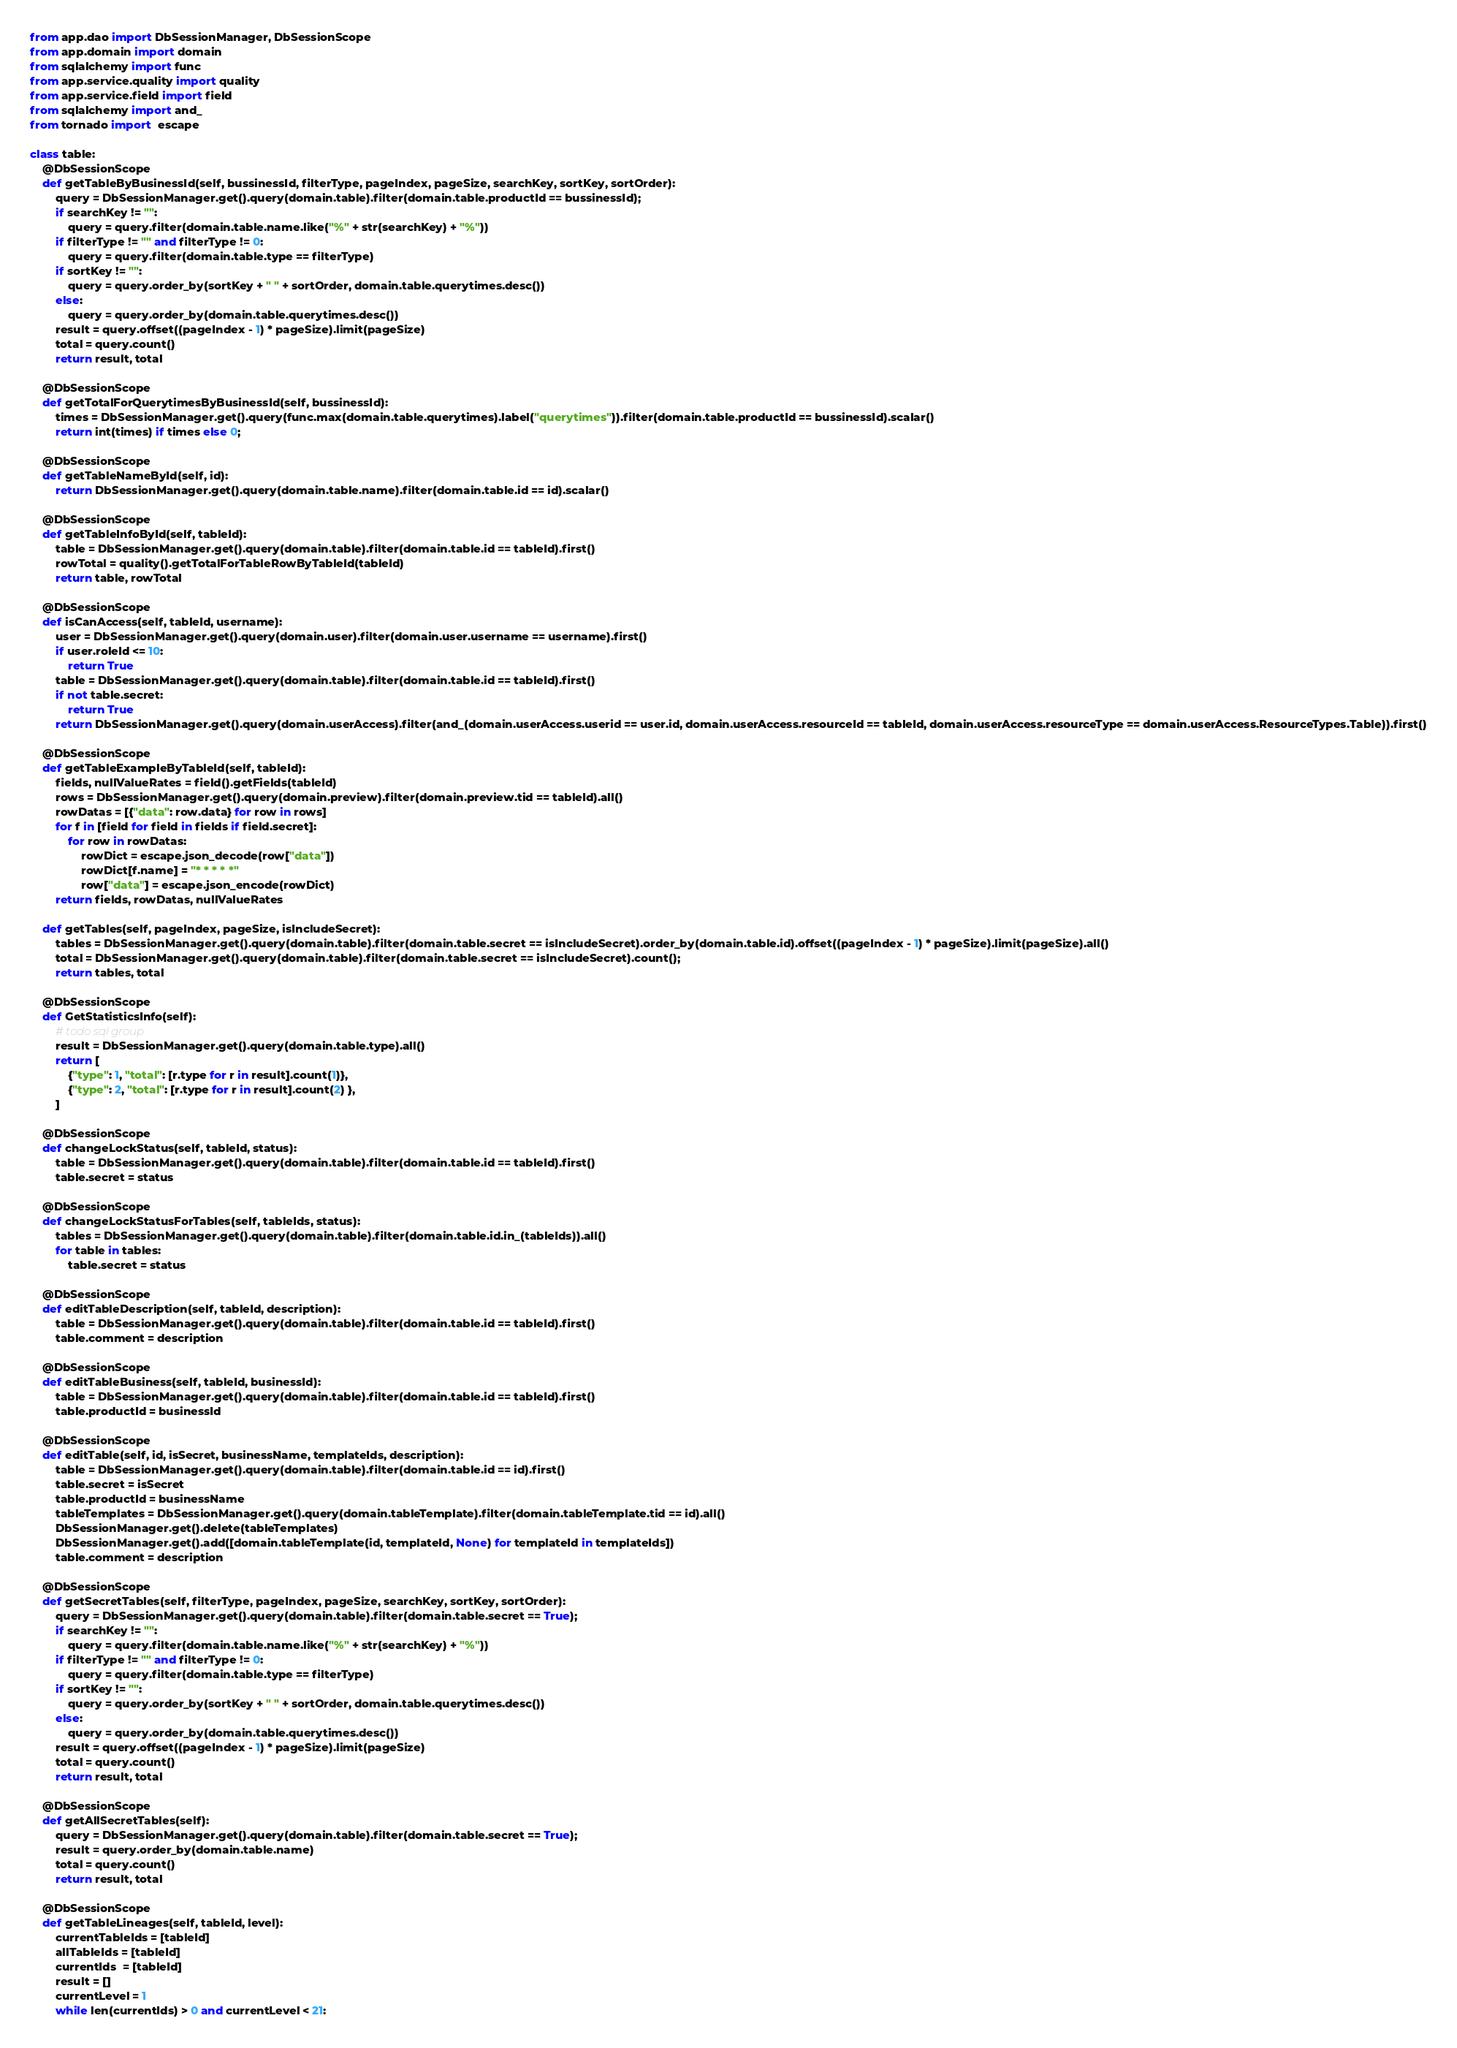<code> <loc_0><loc_0><loc_500><loc_500><_Python_>from app.dao import DbSessionManager, DbSessionScope
from app.domain import domain
from sqlalchemy import func
from app.service.quality import quality
from app.service.field import field
from sqlalchemy import and_
from tornado import  escape

class table:
    @DbSessionScope
    def getTableByBusinessId(self, bussinessId, filterType, pageIndex, pageSize, searchKey, sortKey, sortOrder):
        query = DbSessionManager.get().query(domain.table).filter(domain.table.productId == bussinessId);
        if searchKey != "":
            query = query.filter(domain.table.name.like("%" + str(searchKey) + "%"))
        if filterType != "" and filterType != 0:
            query = query.filter(domain.table.type == filterType)
        if sortKey != "":
            query = query.order_by(sortKey + " " + sortOrder, domain.table.querytimes.desc())
        else:
            query = query.order_by(domain.table.querytimes.desc())
        result = query.offset((pageIndex - 1) * pageSize).limit(pageSize)
        total = query.count()
        return result, total

    @DbSessionScope
    def getTotalForQuerytimesByBusinessId(self, bussinessId):
        times = DbSessionManager.get().query(func.max(domain.table.querytimes).label("querytimes")).filter(domain.table.productId == bussinessId).scalar()
        return int(times) if times else 0;

    @DbSessionScope
    def getTableNameById(self, id):
        return DbSessionManager.get().query(domain.table.name).filter(domain.table.id == id).scalar()

    @DbSessionScope
    def getTableInfoById(self, tableId):
        table = DbSessionManager.get().query(domain.table).filter(domain.table.id == tableId).first()
        rowTotal = quality().getTotalForTableRowByTableId(tableId)
        return table, rowTotal

    @DbSessionScope
    def isCanAccess(self, tableId, username):
        user = DbSessionManager.get().query(domain.user).filter(domain.user.username == username).first()
        if user.roleId <= 10:
            return True
        table = DbSessionManager.get().query(domain.table).filter(domain.table.id == tableId).first()
        if not table.secret:
            return True
        return DbSessionManager.get().query(domain.userAccess).filter(and_(domain.userAccess.userid == user.id, domain.userAccess.resourceId == tableId, domain.userAccess.resourceType == domain.userAccess.ResourceTypes.Table)).first()

    @DbSessionScope
    def getTableExampleByTableId(self, tableId):
        fields, nullValueRates = field().getFields(tableId)
        rows = DbSessionManager.get().query(domain.preview).filter(domain.preview.tid == tableId).all()
        rowDatas = [{"data": row.data} for row in rows]
        for f in [field for field in fields if field.secret]:
            for row in rowDatas:
                rowDict = escape.json_decode(row["data"])
                rowDict[f.name] = "* * * * *"
                row["data"] = escape.json_encode(rowDict)
        return fields, rowDatas, nullValueRates

    def getTables(self, pageIndex, pageSize, isIncludeSecret):
        tables = DbSessionManager.get().query(domain.table).filter(domain.table.secret == isIncludeSecret).order_by(domain.table.id).offset((pageIndex - 1) * pageSize).limit(pageSize).all()
        total = DbSessionManager.get().query(domain.table).filter(domain.table.secret == isIncludeSecret).count();
        return tables, total

    @DbSessionScope
    def GetStatisticsInfo(self):
        # todo sql group
        result = DbSessionManager.get().query(domain.table.type).all()
        return [
            {"type": 1, "total": [r.type for r in result].count(1)},
            {"type": 2, "total": [r.type for r in result].count(2) },
        ]

    @DbSessionScope
    def changeLockStatus(self, tableId, status):
        table = DbSessionManager.get().query(domain.table).filter(domain.table.id == tableId).first()
        table.secret = status

    @DbSessionScope
    def changeLockStatusForTables(self, tableIds, status):
        tables = DbSessionManager.get().query(domain.table).filter(domain.table.id.in_(tableIds)).all()
        for table in tables:
            table.secret = status

    @DbSessionScope
    def editTableDescription(self, tableId, description):
        table = DbSessionManager.get().query(domain.table).filter(domain.table.id == tableId).first()
        table.comment = description

    @DbSessionScope
    def editTableBusiness(self, tableId, businessId):
        table = DbSessionManager.get().query(domain.table).filter(domain.table.id == tableId).first()
        table.productId = businessId

    @DbSessionScope
    def editTable(self, id, isSecret, businessName, templateIds, description):
        table = DbSessionManager.get().query(domain.table).filter(domain.table.id == id).first()
        table.secret = isSecret
        table.productId = businessName
        tableTemplates = DbSessionManager.get().query(domain.tableTemplate).filter(domain.tableTemplate.tid == id).all()
        DbSessionManager.get().delete(tableTemplates)
        DbSessionManager.get().add([domain.tableTemplate(id, templateId, None) for templateId in templateIds])
        table.comment = description

    @DbSessionScope
    def getSecretTables(self, filterType, pageIndex, pageSize, searchKey, sortKey, sortOrder):
        query = DbSessionManager.get().query(domain.table).filter(domain.table.secret == True);
        if searchKey != "":
            query = query.filter(domain.table.name.like("%" + str(searchKey) + "%"))
        if filterType != "" and filterType != 0:
            query = query.filter(domain.table.type == filterType)
        if sortKey != "":
            query = query.order_by(sortKey + " " + sortOrder, domain.table.querytimes.desc())
        else:
            query = query.order_by(domain.table.querytimes.desc())
        result = query.offset((pageIndex - 1) * pageSize).limit(pageSize)
        total = query.count()
        return result, total

    @DbSessionScope
    def getAllSecretTables(self):
        query = DbSessionManager.get().query(domain.table).filter(domain.table.secret == True);
        result = query.order_by(domain.table.name)
        total = query.count()
        return result, total

    @DbSessionScope
    def getTableLineages(self, tableId, level):
        currentTableIds = [tableId]
        allTableIds = [tableId]
        currentIds  = [tableId]
        result = []
        currentLevel = 1
        while len(currentIds) > 0 and currentLevel < 21:</code> 